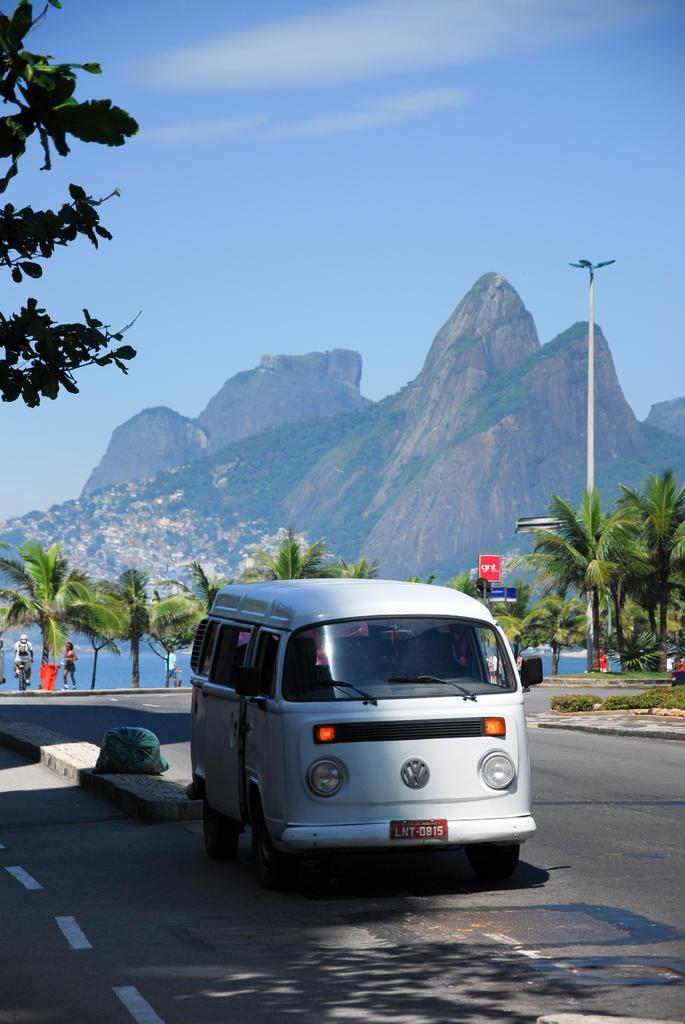What is the main subject of the image? There is a vehicle on the road. What can be seen in the background of the image? There are trees, people, a pole, water, hills, and the sky visible in the background of the image. What type of pleasure can be seen being enjoyed by the vehicle in the image? There is no indication in the image that the vehicle is experiencing any pleasure, as vehicles do not have the ability to experience emotions. 